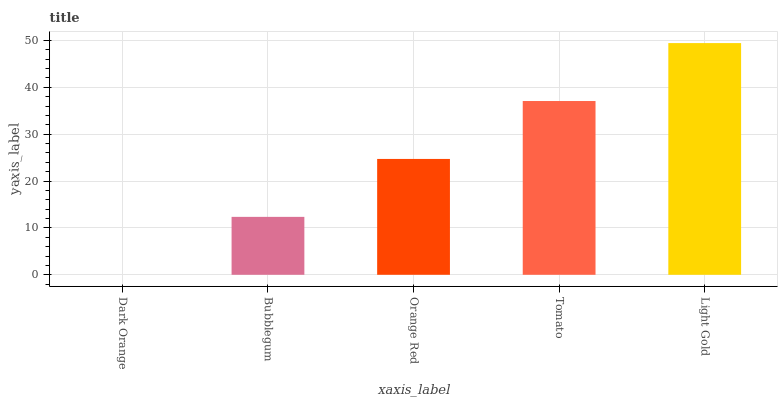Is Dark Orange the minimum?
Answer yes or no. Yes. Is Light Gold the maximum?
Answer yes or no. Yes. Is Bubblegum the minimum?
Answer yes or no. No. Is Bubblegum the maximum?
Answer yes or no. No. Is Bubblegum greater than Dark Orange?
Answer yes or no. Yes. Is Dark Orange less than Bubblegum?
Answer yes or no. Yes. Is Dark Orange greater than Bubblegum?
Answer yes or no. No. Is Bubblegum less than Dark Orange?
Answer yes or no. No. Is Orange Red the high median?
Answer yes or no. Yes. Is Orange Red the low median?
Answer yes or no. Yes. Is Bubblegum the high median?
Answer yes or no. No. Is Light Gold the low median?
Answer yes or no. No. 